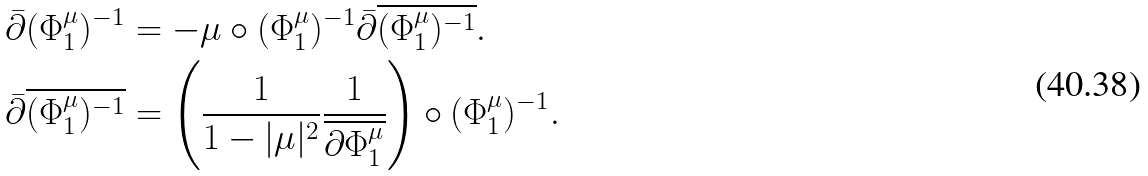<formula> <loc_0><loc_0><loc_500><loc_500>\bar { \partial } ( \Phi _ { 1 } ^ { \mu } ) ^ { - 1 } & = - \mu \circ ( \Phi _ { 1 } ^ { \mu } ) ^ { - 1 } \bar { \partial } \overline { ( \Phi _ { 1 } ^ { \mu } ) ^ { - 1 } } . \\ \bar { \partial } \overline { ( \Phi _ { 1 } ^ { \mu } ) ^ { - 1 } } & = \left ( \frac { 1 } { 1 - | \mu | ^ { 2 } } \frac { 1 } { \overline { \partial \Phi _ { 1 } ^ { \mu } } } \right ) \circ ( \Phi _ { 1 } ^ { \mu } ) ^ { - 1 } .</formula> 